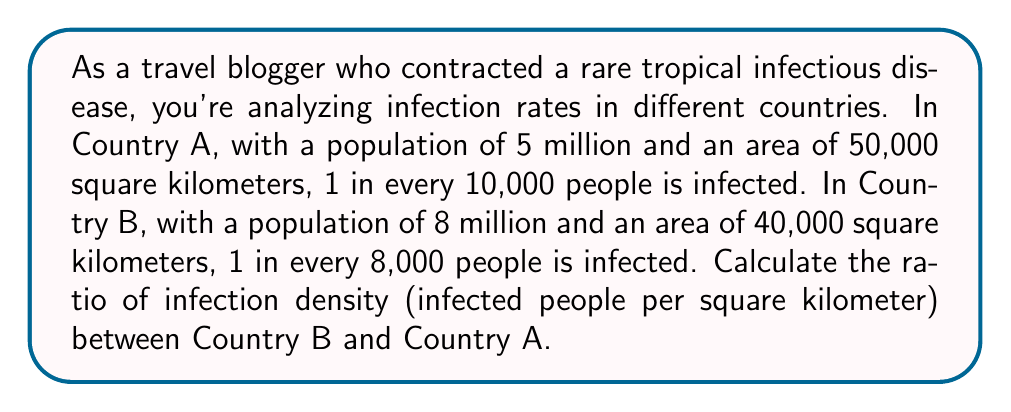Provide a solution to this math problem. Let's approach this step-by-step:

1. Calculate population densities:
   Country A: $\frac{5,000,000}{50,000} = 100$ people/km²
   Country B: $\frac{8,000,000}{40,000} = 200$ people/km²

2. Calculate infection rates:
   Country A: $\frac{1}{10,000} = 0.0001$ or $0.01\%$
   Country B: $\frac{1}{8,000} = 0.000125$ or $0.0125\%$

3. Calculate number of infected people:
   Country A: $5,000,000 \times 0.0001 = 500$ infected
   Country B: $8,000,000 \times 0.000125 = 1,000$ infected

4. Calculate infection density:
   Country A: $\frac{500}{50,000} = 0.01$ infected/km²
   Country B: $\frac{1,000}{40,000} = 0.025$ infected/km²

5. Calculate the ratio of infection densities:
   $\frac{\text{Infection Density B}}{\text{Infection Density A}} = \frac{0.025}{0.01} = \frac{5}{2} = 2.5$
Answer: The ratio of infection density between Country B and Country A is $2.5:1$ or $\frac{5}{2}:1$. 